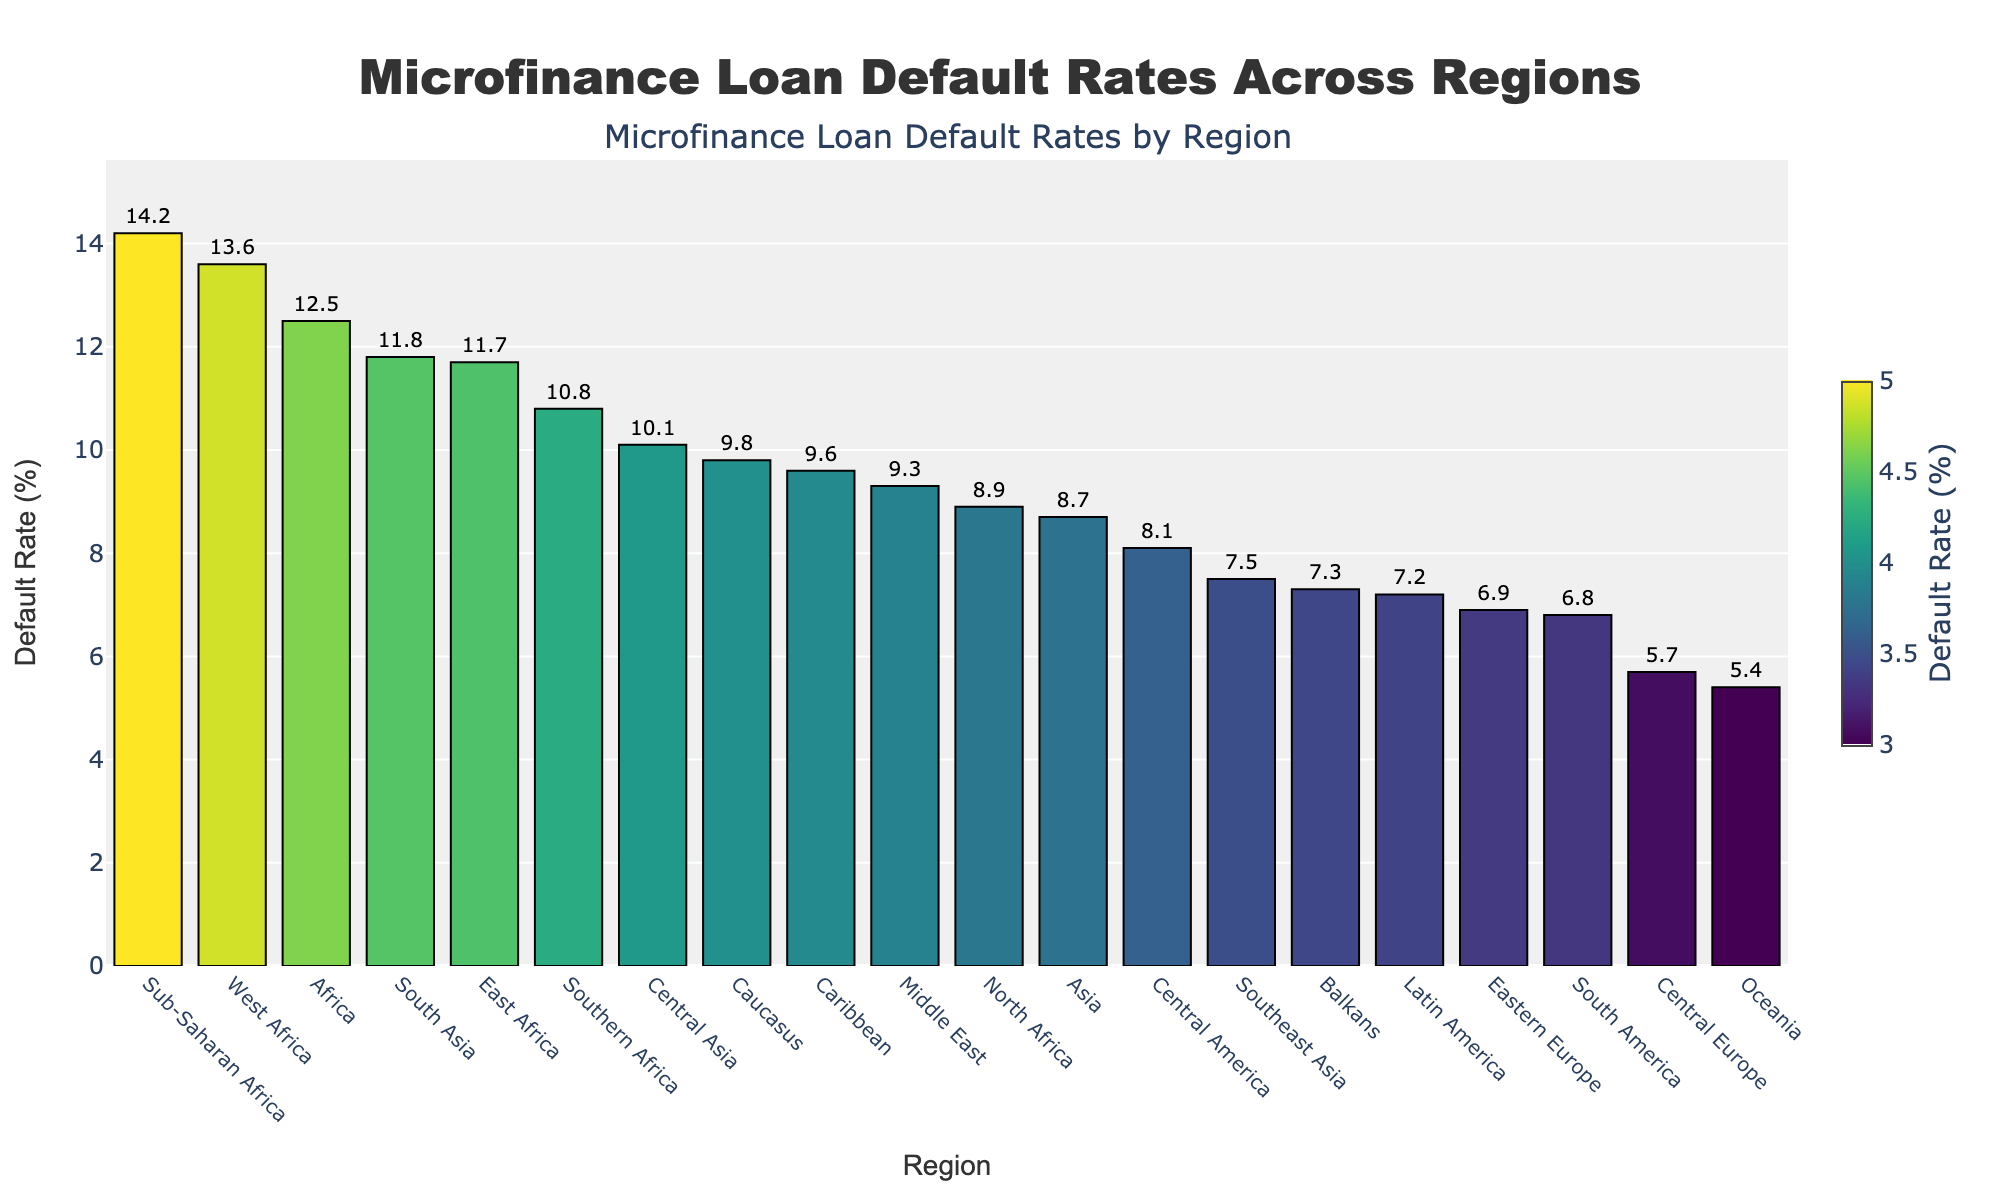Which region has the highest microfinance loan default rate? The plot shows the default rates in various regions and the region with the highest bar corresponds to Sub-Saharan Africa.
Answer: Sub-Saharan Africa Which region has the lowest microfinance loan default rate? The plot shows the default rates in various regions and the region with the smallest bar corresponds to Oceania.
Answer: Oceania What is the default rate in Central Asia? The default rate for each region is indicated by the height of the bar, and Central Asia has a default rate of 10.1%.
Answer: 10.1% What is the difference in default rates between East Africa and West Africa? The default rates are given as 11.7% for East Africa and 13.6% for West Africa. The difference is calculated as 13.6% - 11.7%.
Answer: 1.9% Which region has a higher default rate, Caribbean or Central America? By comparing the heights of the bars, Caribbean has a default rate of 9.6% and Central America has 8.1%. Caribbean has the higher default rate.
Answer: Caribbean What is the average default rate across all regions? Sum all the default rates and divide by the number of regions. (12.5 + 8.7 + 7.2 + 6.9 + 9.3 + 11.8 + 14.2 + 7.5 + 8.1 + 9.6 + 5.4 + 10.1 + 8.9 + 13.6 + 11.7 + 10.8 + 6.8 + 7.3 + 9.8 + 5.7) / 20 = 9.3%.
Answer: 9.3% Identify all regions with a default rate above 10%. Regions with bars extending above the 10% mark are identified: Africa, South Asia, Sub-Saharan Africa, Central Asia, West Africa, East Africa, and Southern Africa.
Answer: Africa, South Asia, Sub-Saharan Africa, Central Asia, West Africa, East Africa, Southern Africa What is the median default rate across all regions? Arrange the default rates in ascending order and find the middle value(s). (5.4, 5.7, 6.8, 6.9, 7.2, 7.3, 7.5, 8.1, 8.7, 8.9, 9.3, 9.6, 9.8, 10.1, 10.8, 11.7, 11.8, 12.5, 13.6, 14.2). The median is the average of the 10th and 11th values: (8.9 + 9.3) / 2 = 9.1%.
Answer: 9.1% What is the total number of regions analyzed in the plot? Count the number of bars representing regions on the x-axis.
Answer: 20 